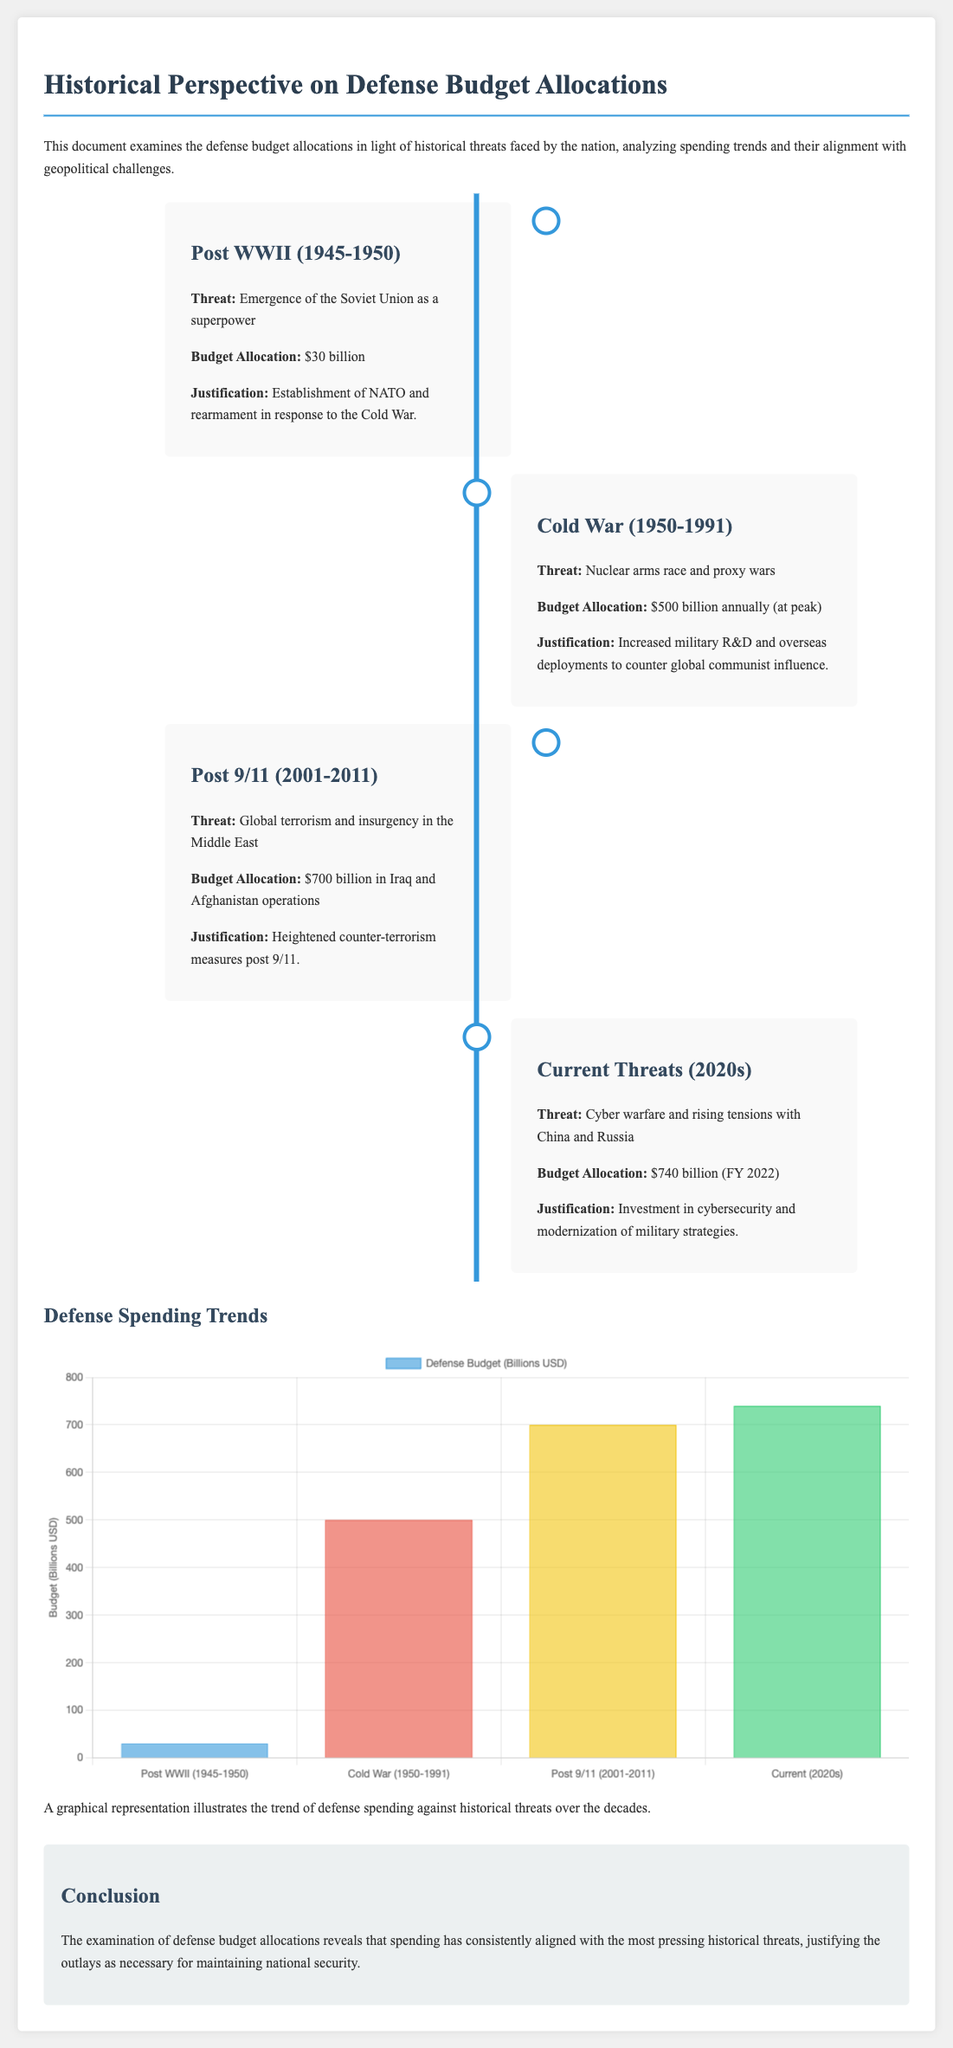What was the defense budget allocation for Post WWII? The budget allocation for Post WWII is stated in the timeline as $30 billion.
Answer: $30 billion What was the peak annual defense budget allocation during the Cold War? The document specifies that the peak budget allocation during the Cold War was $500 billion annually.
Answer: $500 billion annually What major threat was addressed by the defense budget from 2001 to 2011? The timeline indicates that the major threat addressed during this period was global terrorism and insurgency in the Middle East.
Answer: Global terrorism and insurgency in the Middle East What is the defense budget allocation for the current threats in the 2020s? The document states that the defense budget allocation for the 2020s is $740 billion for FY 2022.
Answer: $740 billion How much was spent on Iraq and Afghanistan operations from 2001 to 2011? The document notes that a total of $700 billion was allocated for operations in Iraq and Afghanistan during this timeframe.
Answer: $700 billion What justification is provided for the defense spending post-9/11? The justification provided in the document is heightened counter-terrorism measures post 9/11.
Answer: Heightened counter-terrorism measures How does the document categorize the historical threats covered? The document categorizes historical threats based on major geopolitical events and challenges faced over different periods.
Answer: Major geopolitical events and challenges What visual representation is included to illustrate spending trends? The document includes a bar chart as a graphical representation of defense spending trends.
Answer: Bar chart 